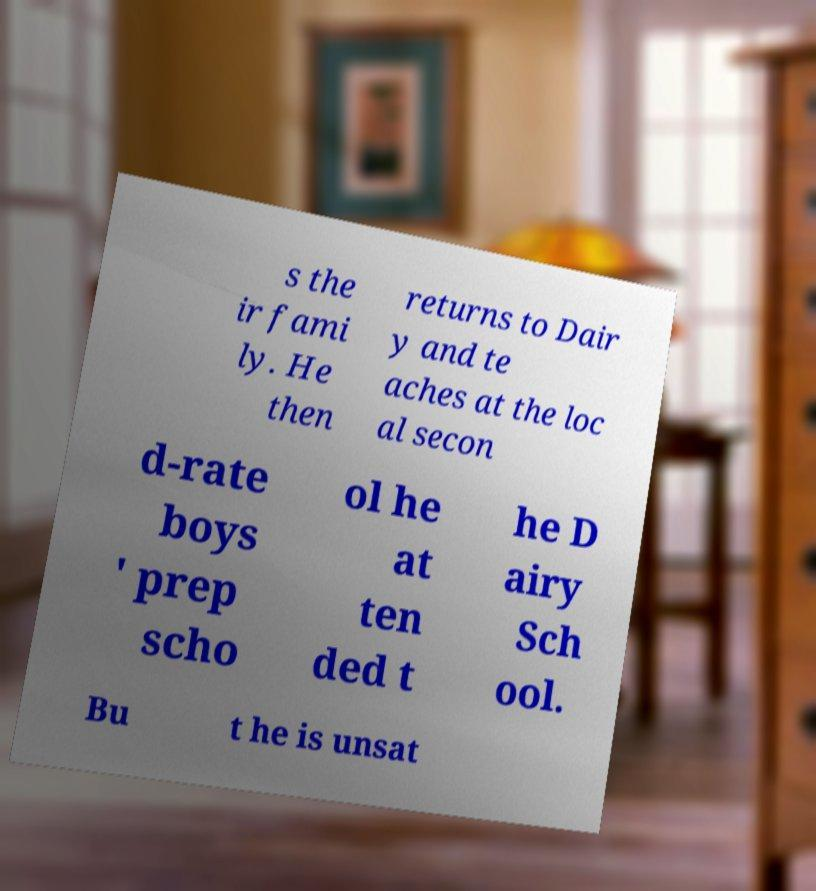For documentation purposes, I need the text within this image transcribed. Could you provide that? s the ir fami ly. He then returns to Dair y and te aches at the loc al secon d-rate boys ' prep scho ol he at ten ded t he D airy Sch ool. Bu t he is unsat 